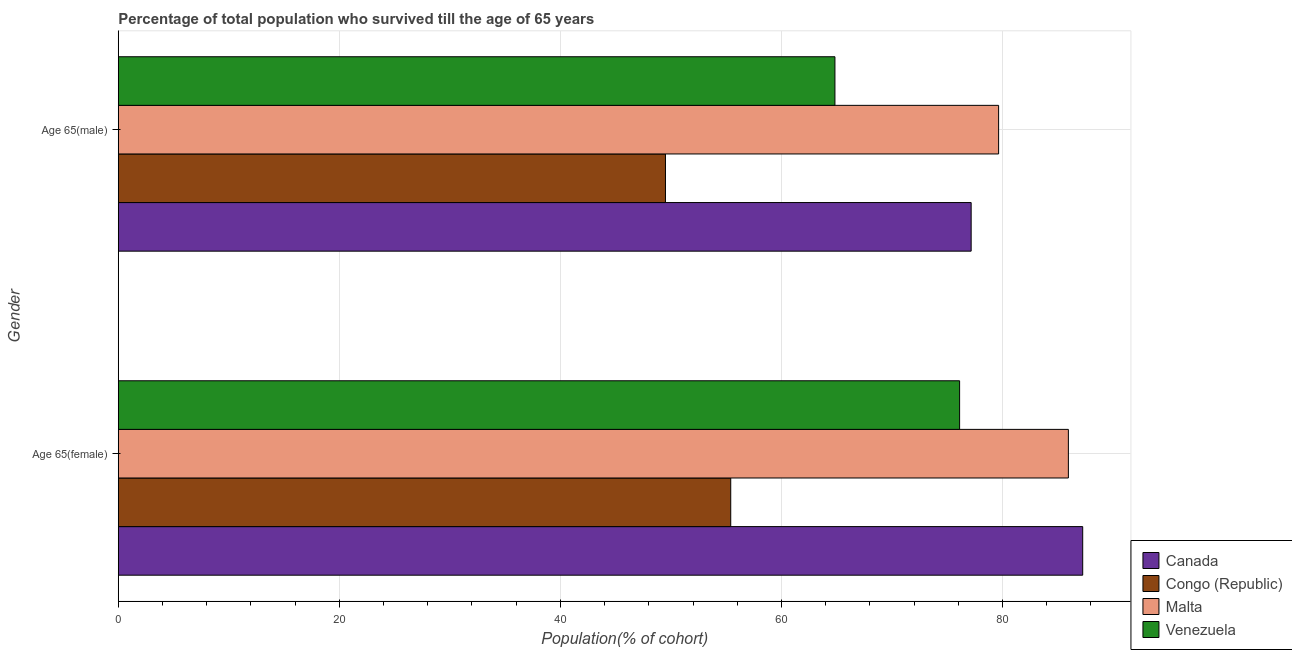How many groups of bars are there?
Your answer should be very brief. 2. Are the number of bars per tick equal to the number of legend labels?
Offer a very short reply. Yes. How many bars are there on the 2nd tick from the bottom?
Keep it short and to the point. 4. What is the label of the 1st group of bars from the top?
Provide a succinct answer. Age 65(male). What is the percentage of male population who survived till age of 65 in Malta?
Your response must be concise. 79.65. Across all countries, what is the maximum percentage of female population who survived till age of 65?
Your answer should be compact. 87.26. Across all countries, what is the minimum percentage of female population who survived till age of 65?
Your answer should be compact. 55.41. In which country was the percentage of male population who survived till age of 65 maximum?
Offer a terse response. Malta. In which country was the percentage of female population who survived till age of 65 minimum?
Give a very brief answer. Congo (Republic). What is the total percentage of female population who survived till age of 65 in the graph?
Make the answer very short. 304.76. What is the difference between the percentage of male population who survived till age of 65 in Malta and that in Congo (Republic)?
Offer a terse response. 30.14. What is the difference between the percentage of male population who survived till age of 65 in Venezuela and the percentage of female population who survived till age of 65 in Congo (Republic)?
Offer a very short reply. 9.43. What is the average percentage of male population who survived till age of 65 per country?
Ensure brevity in your answer.  67.79. What is the difference between the percentage of male population who survived till age of 65 and percentage of female population who survived till age of 65 in Canada?
Offer a terse response. -10.09. In how many countries, is the percentage of male population who survived till age of 65 greater than 80 %?
Offer a terse response. 0. What is the ratio of the percentage of male population who survived till age of 65 in Venezuela to that in Malta?
Offer a very short reply. 0.81. Is the percentage of female population who survived till age of 65 in Malta less than that in Canada?
Your answer should be compact. Yes. In how many countries, is the percentage of female population who survived till age of 65 greater than the average percentage of female population who survived till age of 65 taken over all countries?
Ensure brevity in your answer.  2. What does the 1st bar from the top in Age 65(female) represents?
Provide a succinct answer. Venezuela. What does the 1st bar from the bottom in Age 65(male) represents?
Your answer should be very brief. Canada. How many bars are there?
Your answer should be compact. 8. Are all the bars in the graph horizontal?
Ensure brevity in your answer.  Yes. How many countries are there in the graph?
Provide a short and direct response. 4. Are the values on the major ticks of X-axis written in scientific E-notation?
Make the answer very short. No. How many legend labels are there?
Ensure brevity in your answer.  4. What is the title of the graph?
Offer a very short reply. Percentage of total population who survived till the age of 65 years. What is the label or title of the X-axis?
Ensure brevity in your answer.  Population(% of cohort). What is the label or title of the Y-axis?
Offer a very short reply. Gender. What is the Population(% of cohort) in Canada in Age 65(female)?
Make the answer very short. 87.26. What is the Population(% of cohort) in Congo (Republic) in Age 65(female)?
Provide a succinct answer. 55.41. What is the Population(% of cohort) in Malta in Age 65(female)?
Offer a terse response. 85.96. What is the Population(% of cohort) of Venezuela in Age 65(female)?
Offer a very short reply. 76.12. What is the Population(% of cohort) in Canada in Age 65(male)?
Offer a very short reply. 77.17. What is the Population(% of cohort) in Congo (Republic) in Age 65(male)?
Provide a succinct answer. 49.51. What is the Population(% of cohort) in Malta in Age 65(male)?
Your answer should be compact. 79.65. What is the Population(% of cohort) in Venezuela in Age 65(male)?
Provide a short and direct response. 64.84. Across all Gender, what is the maximum Population(% of cohort) of Canada?
Provide a short and direct response. 87.26. Across all Gender, what is the maximum Population(% of cohort) in Congo (Republic)?
Your response must be concise. 55.41. Across all Gender, what is the maximum Population(% of cohort) of Malta?
Provide a succinct answer. 85.96. Across all Gender, what is the maximum Population(% of cohort) in Venezuela?
Offer a very short reply. 76.12. Across all Gender, what is the minimum Population(% of cohort) of Canada?
Your response must be concise. 77.17. Across all Gender, what is the minimum Population(% of cohort) of Congo (Republic)?
Your answer should be compact. 49.51. Across all Gender, what is the minimum Population(% of cohort) of Malta?
Provide a succinct answer. 79.65. Across all Gender, what is the minimum Population(% of cohort) of Venezuela?
Offer a terse response. 64.84. What is the total Population(% of cohort) of Canada in the graph?
Offer a very short reply. 164.42. What is the total Population(% of cohort) in Congo (Republic) in the graph?
Give a very brief answer. 104.92. What is the total Population(% of cohort) in Malta in the graph?
Offer a very short reply. 165.61. What is the total Population(% of cohort) of Venezuela in the graph?
Ensure brevity in your answer.  140.96. What is the difference between the Population(% of cohort) of Canada in Age 65(female) and that in Age 65(male)?
Your response must be concise. 10.09. What is the difference between the Population(% of cohort) of Congo (Republic) in Age 65(female) and that in Age 65(male)?
Provide a succinct answer. 5.9. What is the difference between the Population(% of cohort) of Malta in Age 65(female) and that in Age 65(male)?
Provide a short and direct response. 6.31. What is the difference between the Population(% of cohort) in Venezuela in Age 65(female) and that in Age 65(male)?
Offer a very short reply. 11.28. What is the difference between the Population(% of cohort) of Canada in Age 65(female) and the Population(% of cohort) of Congo (Republic) in Age 65(male)?
Your response must be concise. 37.75. What is the difference between the Population(% of cohort) of Canada in Age 65(female) and the Population(% of cohort) of Malta in Age 65(male)?
Offer a very short reply. 7.61. What is the difference between the Population(% of cohort) in Canada in Age 65(female) and the Population(% of cohort) in Venezuela in Age 65(male)?
Your response must be concise. 22.42. What is the difference between the Population(% of cohort) of Congo (Republic) in Age 65(female) and the Population(% of cohort) of Malta in Age 65(male)?
Offer a terse response. -24.24. What is the difference between the Population(% of cohort) in Congo (Republic) in Age 65(female) and the Population(% of cohort) in Venezuela in Age 65(male)?
Your response must be concise. -9.43. What is the difference between the Population(% of cohort) in Malta in Age 65(female) and the Population(% of cohort) in Venezuela in Age 65(male)?
Your answer should be very brief. 21.12. What is the average Population(% of cohort) in Canada per Gender?
Give a very brief answer. 82.21. What is the average Population(% of cohort) of Congo (Republic) per Gender?
Your answer should be very brief. 52.46. What is the average Population(% of cohort) in Malta per Gender?
Your answer should be compact. 82.81. What is the average Population(% of cohort) in Venezuela per Gender?
Offer a very short reply. 70.48. What is the difference between the Population(% of cohort) in Canada and Population(% of cohort) in Congo (Republic) in Age 65(female)?
Provide a short and direct response. 31.85. What is the difference between the Population(% of cohort) of Canada and Population(% of cohort) of Malta in Age 65(female)?
Give a very brief answer. 1.3. What is the difference between the Population(% of cohort) of Canada and Population(% of cohort) of Venezuela in Age 65(female)?
Keep it short and to the point. 11.14. What is the difference between the Population(% of cohort) in Congo (Republic) and Population(% of cohort) in Malta in Age 65(female)?
Provide a short and direct response. -30.55. What is the difference between the Population(% of cohort) in Congo (Republic) and Population(% of cohort) in Venezuela in Age 65(female)?
Offer a very short reply. -20.71. What is the difference between the Population(% of cohort) of Malta and Population(% of cohort) of Venezuela in Age 65(female)?
Offer a terse response. 9.84. What is the difference between the Population(% of cohort) of Canada and Population(% of cohort) of Congo (Republic) in Age 65(male)?
Your response must be concise. 27.66. What is the difference between the Population(% of cohort) in Canada and Population(% of cohort) in Malta in Age 65(male)?
Offer a terse response. -2.48. What is the difference between the Population(% of cohort) of Canada and Population(% of cohort) of Venezuela in Age 65(male)?
Provide a short and direct response. 12.32. What is the difference between the Population(% of cohort) in Congo (Republic) and Population(% of cohort) in Malta in Age 65(male)?
Provide a succinct answer. -30.14. What is the difference between the Population(% of cohort) in Congo (Republic) and Population(% of cohort) in Venezuela in Age 65(male)?
Provide a short and direct response. -15.33. What is the difference between the Population(% of cohort) in Malta and Population(% of cohort) in Venezuela in Age 65(male)?
Offer a very short reply. 14.81. What is the ratio of the Population(% of cohort) of Canada in Age 65(female) to that in Age 65(male)?
Provide a succinct answer. 1.13. What is the ratio of the Population(% of cohort) in Congo (Republic) in Age 65(female) to that in Age 65(male)?
Ensure brevity in your answer.  1.12. What is the ratio of the Population(% of cohort) of Malta in Age 65(female) to that in Age 65(male)?
Keep it short and to the point. 1.08. What is the ratio of the Population(% of cohort) in Venezuela in Age 65(female) to that in Age 65(male)?
Your answer should be compact. 1.17. What is the difference between the highest and the second highest Population(% of cohort) in Canada?
Ensure brevity in your answer.  10.09. What is the difference between the highest and the second highest Population(% of cohort) of Congo (Republic)?
Your answer should be very brief. 5.9. What is the difference between the highest and the second highest Population(% of cohort) of Malta?
Give a very brief answer. 6.31. What is the difference between the highest and the second highest Population(% of cohort) of Venezuela?
Make the answer very short. 11.28. What is the difference between the highest and the lowest Population(% of cohort) in Canada?
Your response must be concise. 10.09. What is the difference between the highest and the lowest Population(% of cohort) in Congo (Republic)?
Your answer should be very brief. 5.9. What is the difference between the highest and the lowest Population(% of cohort) in Malta?
Your response must be concise. 6.31. What is the difference between the highest and the lowest Population(% of cohort) in Venezuela?
Keep it short and to the point. 11.28. 